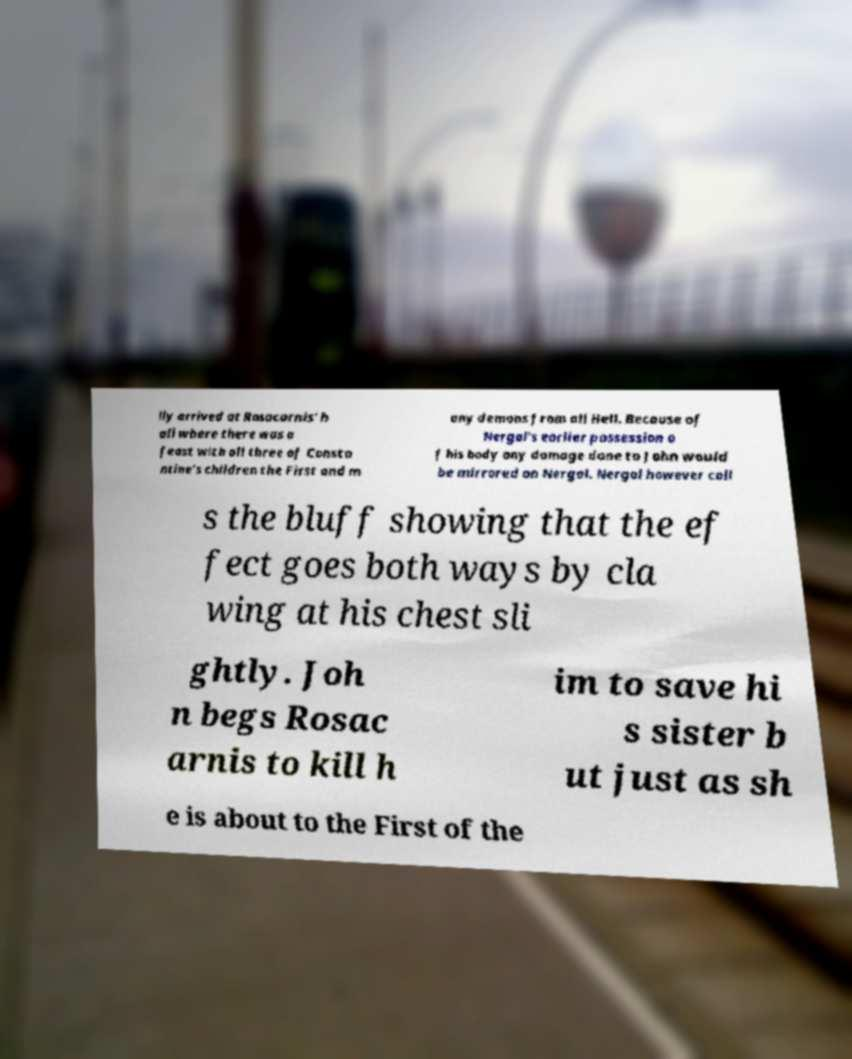For documentation purposes, I need the text within this image transcribed. Could you provide that? lly arrived at Rosacarnis' h all where there was a feast with all three of Consta ntine's children the First and m any demons from all Hell. Because of Nergal's earlier possession o f his body any damage done to John would be mirrored on Nergal. Nergal however call s the bluff showing that the ef fect goes both ways by cla wing at his chest sli ghtly. Joh n begs Rosac arnis to kill h im to save hi s sister b ut just as sh e is about to the First of the 